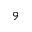<formula> <loc_0><loc_0><loc_500><loc_500>^ { 9 }</formula> 